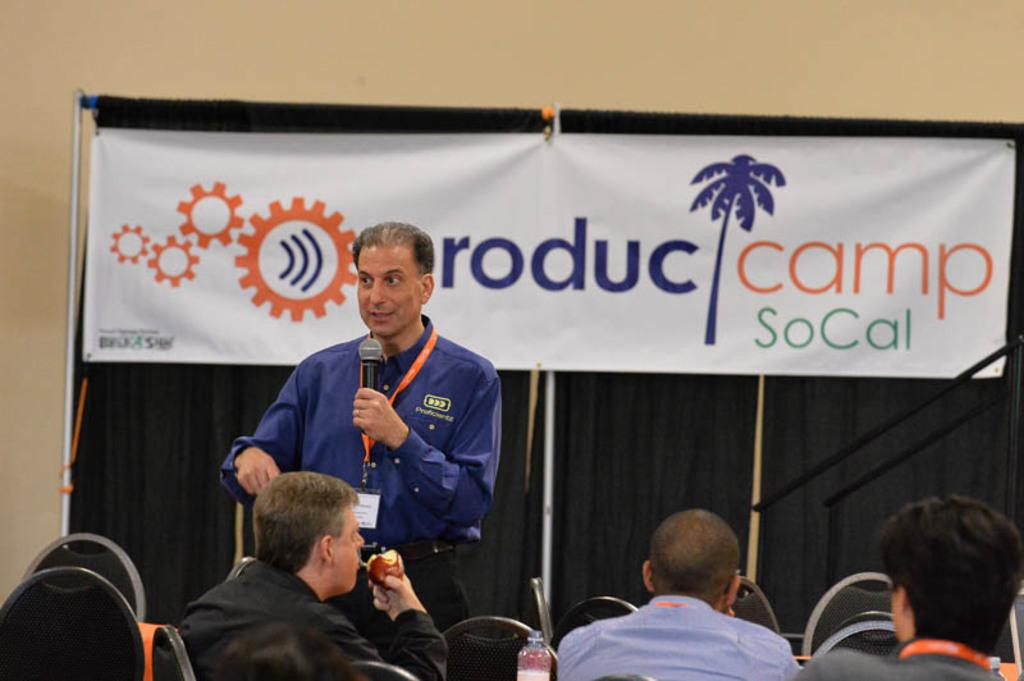What type of structure can be seen in the image? There is a wall in the image. What is hanging on the wall in the image? There is a banner in the image. What are the people in the image doing? The people are sitting on chairs in the image. What is the man in the image doing? The man is standing in the image and holding a microphone. What type of tank is visible in the image? There is no tank present in the image. What form does the banner take in the image? The banner is hanging on the wall, but its specific form or shape cannot be determined from the image. 